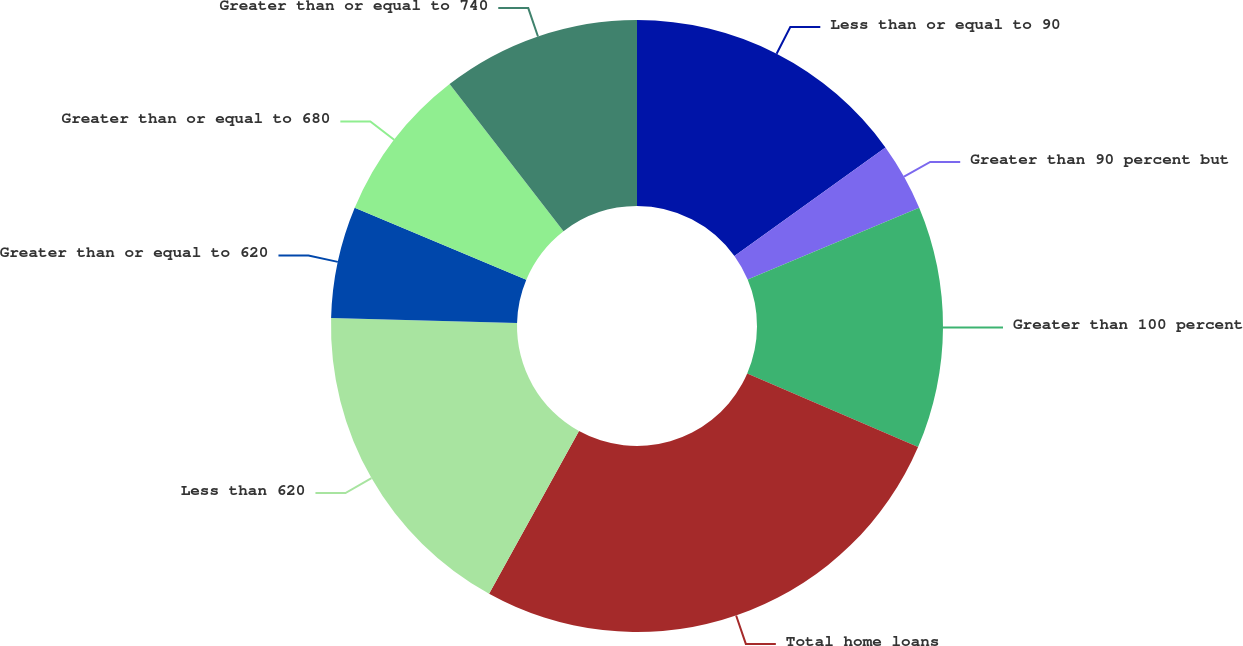Convert chart to OTSL. <chart><loc_0><loc_0><loc_500><loc_500><pie_chart><fcel>Less than or equal to 90<fcel>Greater than 90 percent but<fcel>Greater than 100 percent<fcel>Total home loans<fcel>Less than 620<fcel>Greater than or equal to 620<fcel>Greater than or equal to 680<fcel>Greater than or equal to 740<nl><fcel>15.08%<fcel>3.6%<fcel>12.79%<fcel>26.56%<fcel>17.38%<fcel>5.9%<fcel>8.2%<fcel>10.49%<nl></chart> 